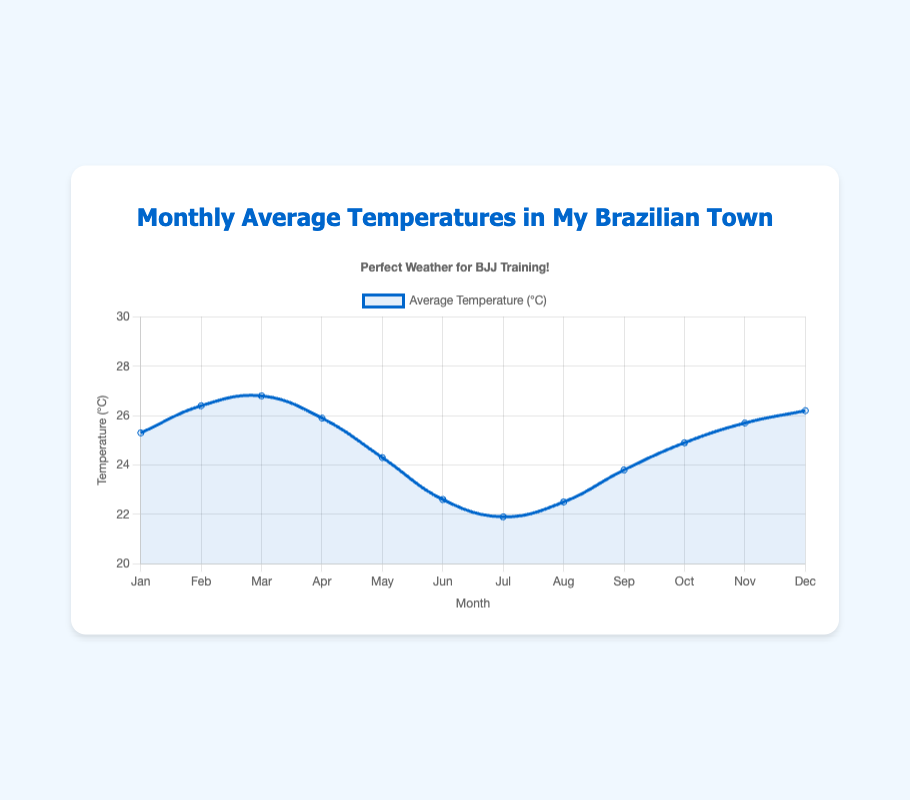What is the average temperature in March? March shows an average temperature of 26.8°C on the y-axis and is indicated by the data point for March (the third point from the beginning) on the x-axis.
Answer: 26.8°C Which month has the highest average temperature? By visually checking each data point on the plot, February and March have the highest average temperatures. Nonetheless, March has a minor lead making it the warmest month.
Answer: March What is the average temperature in December, and how does it compare to that in January? The average temperature in December is 26.2°C from the data, while January's temperature is 25.3°C. December's temperature is slightly higher.
Answer: December is higher Which month between June and September has a lower average temperature? The plot shows the data points for June (22.6°C) and September (23.8°C) on the y-axis. June has a lower average temperature.
Answer: June Calculate the average temperature from May to August. Sum the average temperatures (24.3 + 22.6 + 21.9 + 22.5) = 91.3°C. Then divide by 4 for the number of months (91.3 / 4 = 22.825).
Answer: 22.8°C Which month experiences the steepest drop in average temperature? Visually identifying the significant declines between consecutive months, May to June shows a noticeable drop from 24.3°C to 22.6°C (Δ = 24.3 - 22.6 = 1.7°C).
Answer: May to June During which period does the temperature increase make a noticeable peak? Observing the temperature curve, September to November shows a significant increase from 23.8°C to 25.7°C, making this period a peak.
Answer: September to November How does the temperature in July compare to that in April and December? July (21.9°C) is cooler than April (25.9°C) and December (26.2°C) as observed on the plot.
Answer: July is cooler Is there a visible trend in temperature changes from January to July? The trend shows a slight increase from January to March, then a noticeable decline reaching the lowest point in July. The data points are connected by a line showing this descending trend.
Answer: Yes, decreasing trend Which two consecutive months have the smallest temperature difference? By closely inspecting each pair of consecutive months, April to May sustains a tiny shift, from 25.9°C to 24.3°C, a difference of only 1.6°C.
Answer: April to May 